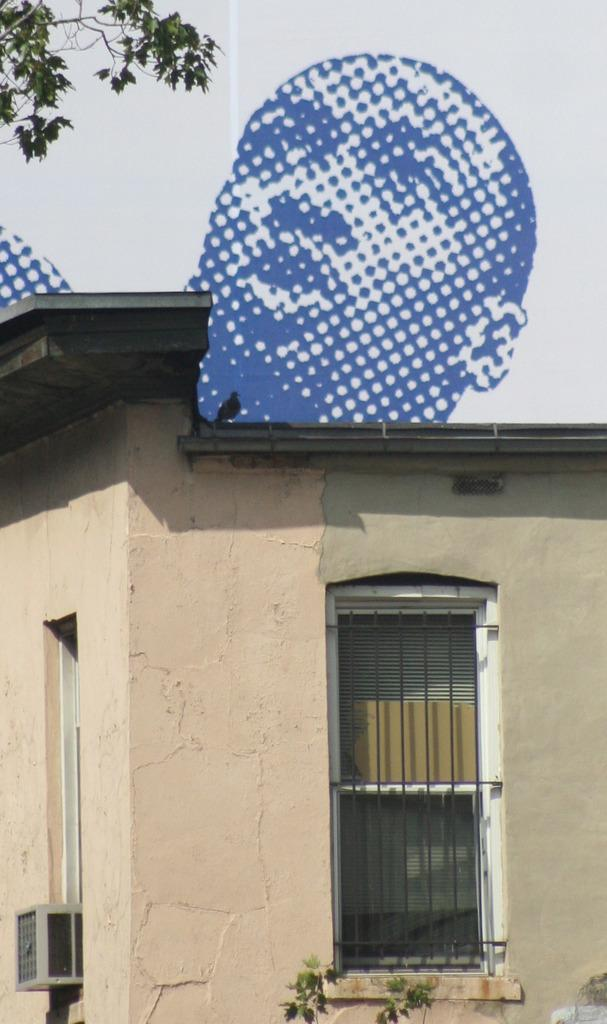What type of structure is in the image? There is a small house in the image. What feature can be seen on the house? The house has a window. What can be seen in the background of the image? In the background, there is a mosaic image. What elements are included in the mosaic image? The mosaic image includes a person and leaves. How does the flame affect the jam in the image? There is no flame or jam present in the image. 